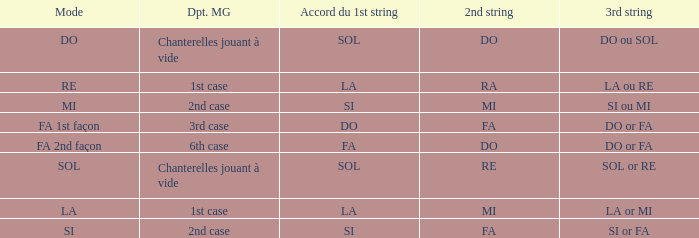Could you parse the entire table as a dict? {'header': ['Mode', 'Dpt. MG', 'Accord du 1st string', '2nd string', '3rd string'], 'rows': [['DO', 'Chanterelles jouant à vide', 'SOL', 'DO', 'DO ou SOL'], ['RE', '1st case', 'LA', 'RA', 'LA ou RE'], ['MI', '2nd case', 'SI', 'MI', 'SI ou MI'], ['FA 1st façon', '3rd case', 'DO', 'FA', 'DO or FA'], ['FA 2nd façon', '6th case', 'FA', 'DO', 'DO or FA'], ['SOL', 'Chanterelles jouant à vide', 'SOL', 'RE', 'SOL or RE'], ['LA', '1st case', 'LA', 'MI', 'LA or MI'], ['SI', '2nd case', 'SI', 'FA', 'SI or FA']]} What is the Depart de la main gauche of the do Mode? Chanterelles jouant à vide. 